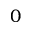<formula> <loc_0><loc_0><loc_500><loc_500>0</formula> 